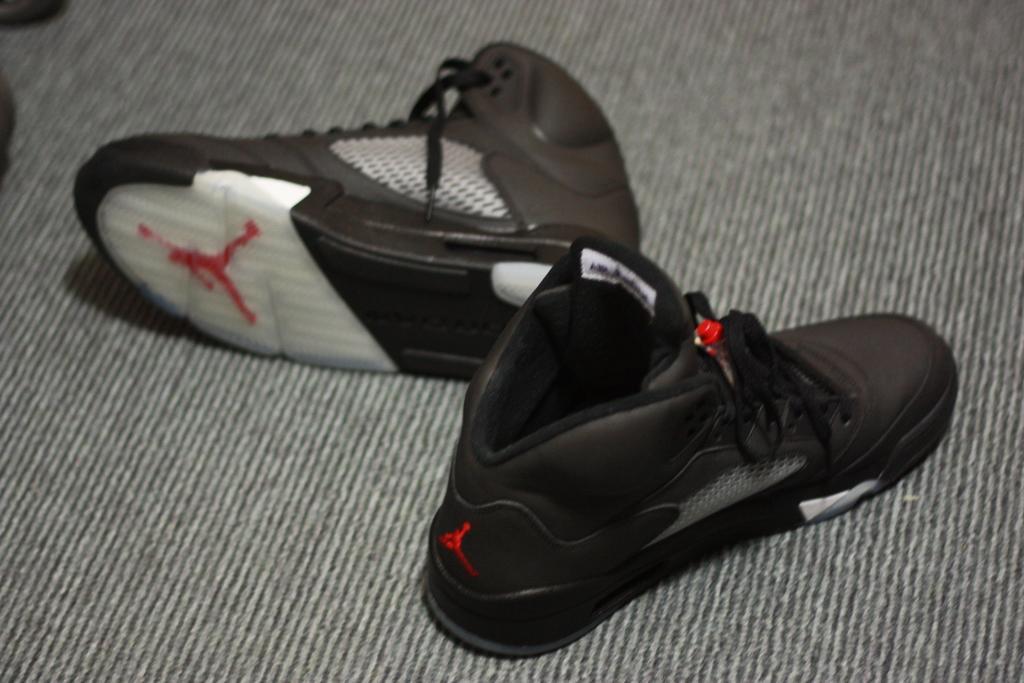In one or two sentences, can you explain what this image depicts? In this image there is a pair of shoes on the carpet. 